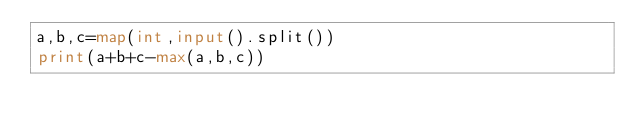Convert code to text. <code><loc_0><loc_0><loc_500><loc_500><_Python_>a,b,c=map(int,input().split())
print(a+b+c-max(a,b,c))</code> 